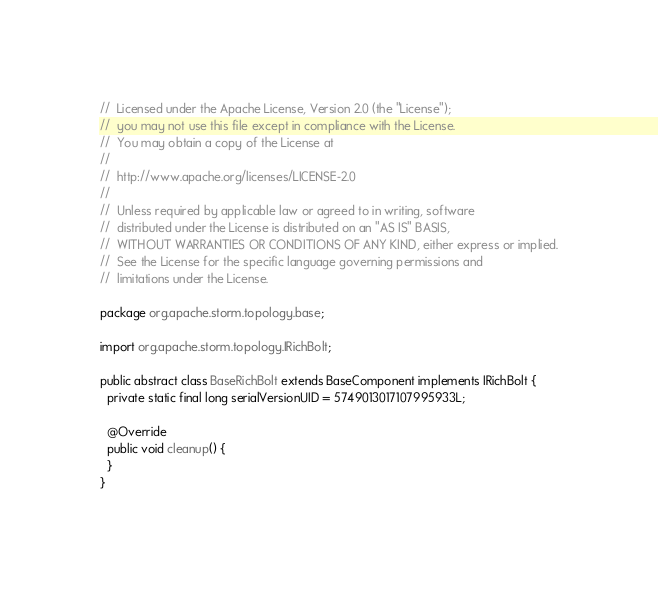<code> <loc_0><loc_0><loc_500><loc_500><_Java_>//  Licensed under the Apache License, Version 2.0 (the "License");
//  you may not use this file except in compliance with the License.
//  You may obtain a copy of the License at
//
//  http://www.apache.org/licenses/LICENSE-2.0
//
//  Unless required by applicable law or agreed to in writing, software
//  distributed under the License is distributed on an "AS IS" BASIS,
//  WITHOUT WARRANTIES OR CONDITIONS OF ANY KIND, either express or implied.
//  See the License for the specific language governing permissions and
//  limitations under the License.

package org.apache.storm.topology.base;

import org.apache.storm.topology.IRichBolt;

public abstract class BaseRichBolt extends BaseComponent implements IRichBolt {
  private static final long serialVersionUID = 5749013017107995933L;

  @Override
  public void cleanup() {
  }
}
</code> 